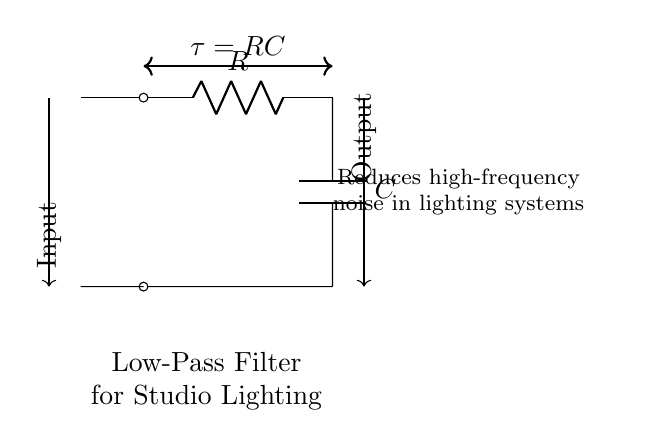What type of components are used in this filter circuit? The circuit contains a resistor and a capacitor, which are the key components of a low-pass filter. The resistor is labeled as R, and the capacitor is labeled as C in the diagram.
Answer: Resistor and capacitor What does the arrow direction indicate in the input-output connections? The arrows indicate the direction of current flow from the input to the output, meaning that the signal enters the circuit at the input and exits at the output.
Answer: Current flow direction What is the time constant of this low-pass filter? The time constant is denoted as tau and is calculated using the formula tau equals R multiplied by C. Based on the circuit, this shows the relationship between the resistor and capacitor in influencing the filter's response time.
Answer: RC What does the label describe about the function of this circuit? The circuit is labeled "Reduces high-frequency noise in lighting systems," indicating its specific purpose in filtering out unwanted high-frequency signals from the studio lighting output.
Answer: Reduces high-frequency noise How does the output signal compare to the input signal? The output signal will be a smoother version of the input signal, particularly attenuating any high-frequency components that were present in the input due to the filtering action of the resistor and capacitor.
Answer: Smoother output signal 